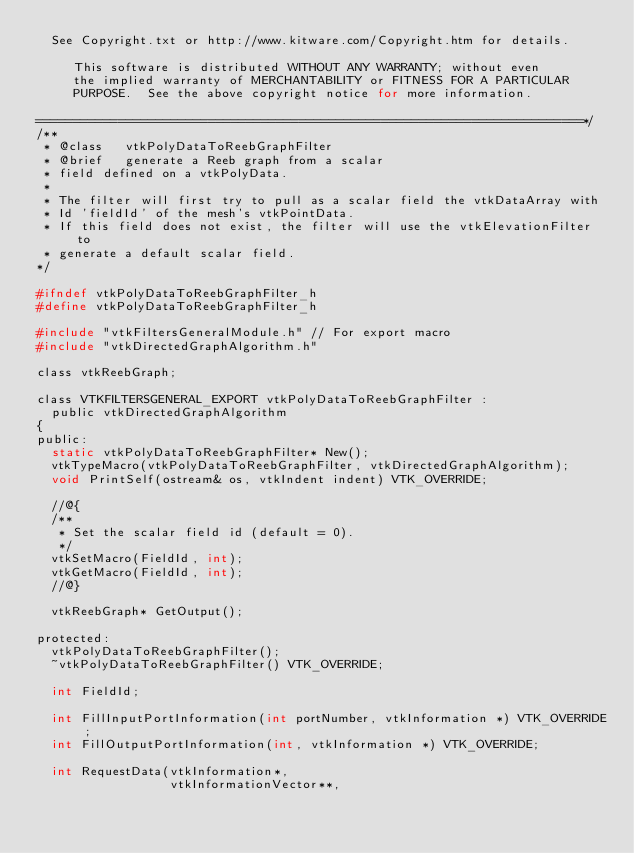Convert code to text. <code><loc_0><loc_0><loc_500><loc_500><_C_>  See Copyright.txt or http://www.kitware.com/Copyright.htm for details.

     This software is distributed WITHOUT ANY WARRANTY; without even
     the implied warranty of MERCHANTABILITY or FITNESS FOR A PARTICULAR
     PURPOSE.  See the above copyright notice for more information.

=========================================================================*/
/**
 * @class   vtkPolyDataToReebGraphFilter
 * @brief   generate a Reeb graph from a scalar
 * field defined on a vtkPolyData.
 *
 * The filter will first try to pull as a scalar field the vtkDataArray with
 * Id 'fieldId' of the mesh's vtkPointData.
 * If this field does not exist, the filter will use the vtkElevationFilter to
 * generate a default scalar field.
*/

#ifndef vtkPolyDataToReebGraphFilter_h
#define vtkPolyDataToReebGraphFilter_h

#include "vtkFiltersGeneralModule.h" // For export macro
#include "vtkDirectedGraphAlgorithm.h"

class vtkReebGraph;

class VTKFILTERSGENERAL_EXPORT vtkPolyDataToReebGraphFilter :
  public vtkDirectedGraphAlgorithm
{
public:
  static vtkPolyDataToReebGraphFilter* New();
  vtkTypeMacro(vtkPolyDataToReebGraphFilter, vtkDirectedGraphAlgorithm);
  void PrintSelf(ostream& os, vtkIndent indent) VTK_OVERRIDE;

  //@{
  /**
   * Set the scalar field id (default = 0).
   */
  vtkSetMacro(FieldId, int);
  vtkGetMacro(FieldId, int);
  //@}

  vtkReebGraph* GetOutput();

protected:
  vtkPolyDataToReebGraphFilter();
  ~vtkPolyDataToReebGraphFilter() VTK_OVERRIDE;

  int FieldId;

  int FillInputPortInformation(int portNumber, vtkInformation *) VTK_OVERRIDE;
  int FillOutputPortInformation(int, vtkInformation *) VTK_OVERRIDE;

  int RequestData(vtkInformation*,
                  vtkInformationVector**,</code> 